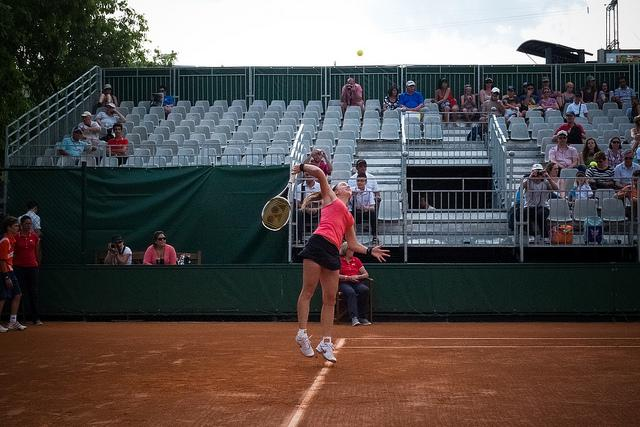What type of shot is the woman about to hit? Please explain your reasoning. serve. The shot is a serve. 